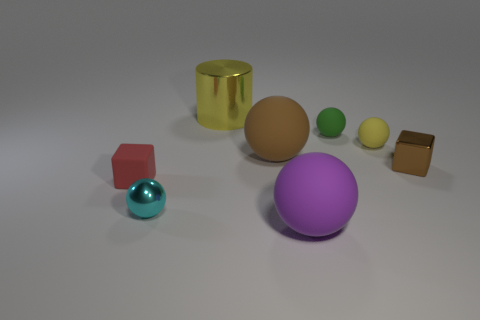Are there fewer yellow things left of the cylinder than tiny brown cubes to the left of the purple sphere?
Provide a short and direct response. No. What number of other things are the same shape as the green matte object?
Provide a short and direct response. 4. There is a cube behind the small matte object that is to the left of the brown matte thing on the right side of the cyan ball; how big is it?
Provide a short and direct response. Small. What number of gray things are either matte spheres or small shiny things?
Your response must be concise. 0. What is the shape of the big rubber object that is right of the big rubber ball that is behind the tiny metallic cube?
Your response must be concise. Sphere. There is a purple ball that is in front of the large shiny thing; does it have the same size as the metallic thing right of the yellow rubber thing?
Give a very brief answer. No. Is there a tiny cyan thing made of the same material as the yellow sphere?
Make the answer very short. No. The rubber sphere that is the same color as the cylinder is what size?
Provide a short and direct response. Small. Are there any small yellow rubber spheres in front of the thing that is right of the yellow thing that is right of the large yellow thing?
Your response must be concise. No. There is a red rubber block; are there any big cylinders in front of it?
Keep it short and to the point. No. 